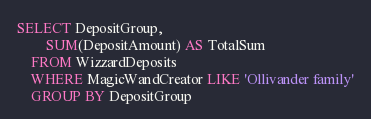Convert code to text. <code><loc_0><loc_0><loc_500><loc_500><_SQL_>SELECT DepositGroup,
		SUM(DepositAmount) AS TotalSum
	FROM WizzardDeposits
	WHERE MagicWandCreator LIKE 'Ollivander family'
	GROUP BY DepositGroup</code> 